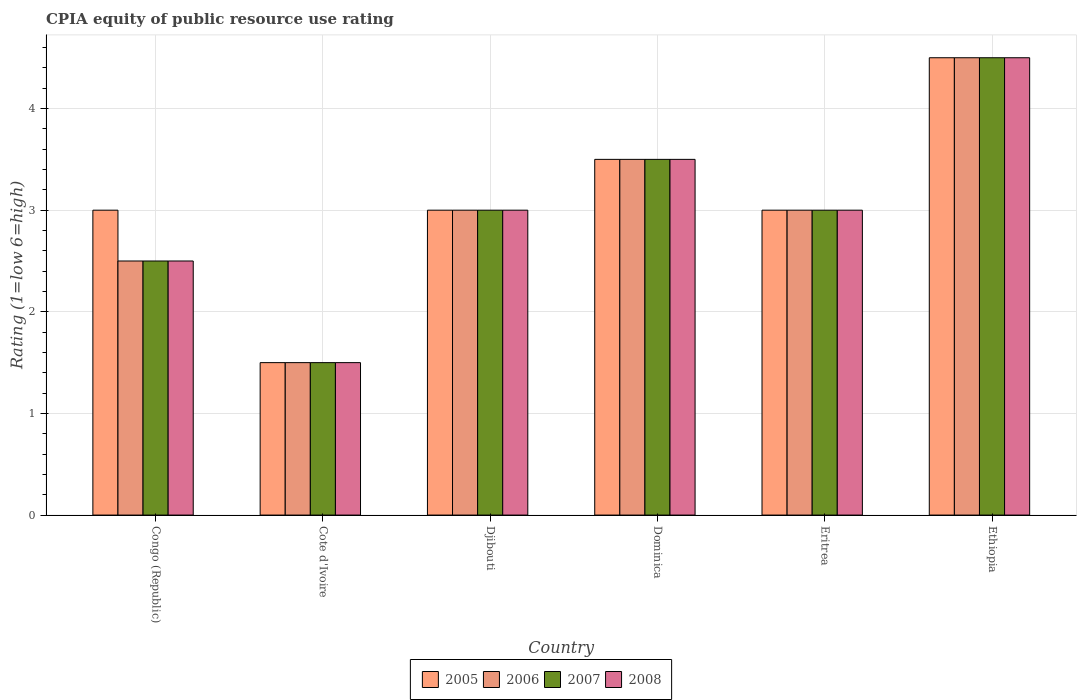How many different coloured bars are there?
Offer a very short reply. 4. How many groups of bars are there?
Give a very brief answer. 6. Are the number of bars on each tick of the X-axis equal?
Your response must be concise. Yes. What is the label of the 5th group of bars from the left?
Keep it short and to the point. Eritrea. Across all countries, what is the maximum CPIA rating in 2007?
Provide a short and direct response. 4.5. In which country was the CPIA rating in 2005 maximum?
Your answer should be compact. Ethiopia. In which country was the CPIA rating in 2005 minimum?
Offer a very short reply. Cote d'Ivoire. What is the total CPIA rating in 2006 in the graph?
Provide a succinct answer. 18. What is the difference between the CPIA rating in 2008 in Congo (Republic) and the CPIA rating in 2005 in Cote d'Ivoire?
Keep it short and to the point. 1. What is the difference between the CPIA rating of/in 2006 and CPIA rating of/in 2007 in Dominica?
Your response must be concise. 0. What is the ratio of the CPIA rating in 2005 in Congo (Republic) to that in Dominica?
Your answer should be very brief. 0.86. In how many countries, is the CPIA rating in 2005 greater than the average CPIA rating in 2005 taken over all countries?
Your response must be concise. 2. Is it the case that in every country, the sum of the CPIA rating in 2006 and CPIA rating in 2007 is greater than the sum of CPIA rating in 2008 and CPIA rating in 2005?
Your response must be concise. No. What does the 2nd bar from the left in Djibouti represents?
Offer a very short reply. 2006. Is it the case that in every country, the sum of the CPIA rating in 2007 and CPIA rating in 2006 is greater than the CPIA rating in 2008?
Offer a very short reply. Yes. Are all the bars in the graph horizontal?
Provide a succinct answer. No. Does the graph contain grids?
Keep it short and to the point. Yes. Where does the legend appear in the graph?
Keep it short and to the point. Bottom center. How many legend labels are there?
Provide a succinct answer. 4. What is the title of the graph?
Make the answer very short. CPIA equity of public resource use rating. What is the label or title of the Y-axis?
Provide a succinct answer. Rating (1=low 6=high). What is the Rating (1=low 6=high) in 2005 in Congo (Republic)?
Make the answer very short. 3. What is the Rating (1=low 6=high) in 2007 in Congo (Republic)?
Give a very brief answer. 2.5. What is the Rating (1=low 6=high) in 2008 in Congo (Republic)?
Make the answer very short. 2.5. What is the Rating (1=low 6=high) of 2005 in Cote d'Ivoire?
Your answer should be compact. 1.5. What is the Rating (1=low 6=high) of 2007 in Cote d'Ivoire?
Provide a short and direct response. 1.5. What is the Rating (1=low 6=high) of 2008 in Cote d'Ivoire?
Your answer should be very brief. 1.5. What is the Rating (1=low 6=high) of 2005 in Djibouti?
Make the answer very short. 3. What is the Rating (1=low 6=high) in 2006 in Djibouti?
Offer a very short reply. 3. What is the Rating (1=low 6=high) of 2007 in Djibouti?
Provide a succinct answer. 3. What is the Rating (1=low 6=high) of 2008 in Djibouti?
Offer a very short reply. 3. What is the Rating (1=low 6=high) of 2007 in Dominica?
Keep it short and to the point. 3.5. What is the Rating (1=low 6=high) of 2006 in Eritrea?
Make the answer very short. 3. What is the Rating (1=low 6=high) of 2007 in Eritrea?
Keep it short and to the point. 3. What is the Rating (1=low 6=high) in 2008 in Eritrea?
Your answer should be very brief. 3. Across all countries, what is the minimum Rating (1=low 6=high) of 2005?
Provide a short and direct response. 1.5. Across all countries, what is the minimum Rating (1=low 6=high) in 2006?
Your answer should be very brief. 1.5. Across all countries, what is the minimum Rating (1=low 6=high) of 2007?
Ensure brevity in your answer.  1.5. What is the total Rating (1=low 6=high) of 2005 in the graph?
Your response must be concise. 18.5. What is the total Rating (1=low 6=high) of 2007 in the graph?
Provide a short and direct response. 18. What is the difference between the Rating (1=low 6=high) of 2005 in Congo (Republic) and that in Cote d'Ivoire?
Provide a succinct answer. 1.5. What is the difference between the Rating (1=low 6=high) in 2007 in Congo (Republic) and that in Cote d'Ivoire?
Ensure brevity in your answer.  1. What is the difference between the Rating (1=low 6=high) in 2008 in Congo (Republic) and that in Cote d'Ivoire?
Make the answer very short. 1. What is the difference between the Rating (1=low 6=high) in 2008 in Congo (Republic) and that in Djibouti?
Keep it short and to the point. -0.5. What is the difference between the Rating (1=low 6=high) of 2006 in Congo (Republic) and that in Dominica?
Your answer should be compact. -1. What is the difference between the Rating (1=low 6=high) of 2007 in Congo (Republic) and that in Dominica?
Make the answer very short. -1. What is the difference between the Rating (1=low 6=high) of 2008 in Congo (Republic) and that in Dominica?
Ensure brevity in your answer.  -1. What is the difference between the Rating (1=low 6=high) in 2008 in Congo (Republic) and that in Eritrea?
Provide a short and direct response. -0.5. What is the difference between the Rating (1=low 6=high) in 2005 in Congo (Republic) and that in Ethiopia?
Your answer should be compact. -1.5. What is the difference between the Rating (1=low 6=high) in 2006 in Congo (Republic) and that in Ethiopia?
Your answer should be very brief. -2. What is the difference between the Rating (1=low 6=high) of 2007 in Congo (Republic) and that in Ethiopia?
Ensure brevity in your answer.  -2. What is the difference between the Rating (1=low 6=high) of 2008 in Congo (Republic) and that in Ethiopia?
Provide a succinct answer. -2. What is the difference between the Rating (1=low 6=high) in 2005 in Cote d'Ivoire and that in Djibouti?
Make the answer very short. -1.5. What is the difference between the Rating (1=low 6=high) in 2007 in Cote d'Ivoire and that in Djibouti?
Provide a short and direct response. -1.5. What is the difference between the Rating (1=low 6=high) of 2005 in Cote d'Ivoire and that in Dominica?
Keep it short and to the point. -2. What is the difference between the Rating (1=low 6=high) in 2007 in Cote d'Ivoire and that in Dominica?
Offer a very short reply. -2. What is the difference between the Rating (1=low 6=high) in 2008 in Cote d'Ivoire and that in Dominica?
Offer a terse response. -2. What is the difference between the Rating (1=low 6=high) in 2006 in Cote d'Ivoire and that in Eritrea?
Offer a very short reply. -1.5. What is the difference between the Rating (1=low 6=high) of 2005 in Cote d'Ivoire and that in Ethiopia?
Provide a succinct answer. -3. What is the difference between the Rating (1=low 6=high) of 2006 in Cote d'Ivoire and that in Ethiopia?
Your answer should be very brief. -3. What is the difference between the Rating (1=low 6=high) in 2007 in Cote d'Ivoire and that in Ethiopia?
Provide a succinct answer. -3. What is the difference between the Rating (1=low 6=high) in 2008 in Cote d'Ivoire and that in Ethiopia?
Provide a succinct answer. -3. What is the difference between the Rating (1=low 6=high) of 2006 in Djibouti and that in Dominica?
Keep it short and to the point. -0.5. What is the difference between the Rating (1=low 6=high) of 2008 in Djibouti and that in Dominica?
Make the answer very short. -0.5. What is the difference between the Rating (1=low 6=high) of 2005 in Djibouti and that in Eritrea?
Your answer should be compact. 0. What is the difference between the Rating (1=low 6=high) of 2006 in Djibouti and that in Eritrea?
Offer a very short reply. 0. What is the difference between the Rating (1=low 6=high) of 2007 in Djibouti and that in Eritrea?
Keep it short and to the point. 0. What is the difference between the Rating (1=low 6=high) in 2008 in Djibouti and that in Eritrea?
Your answer should be compact. 0. What is the difference between the Rating (1=low 6=high) in 2005 in Djibouti and that in Ethiopia?
Give a very brief answer. -1.5. What is the difference between the Rating (1=low 6=high) in 2006 in Djibouti and that in Ethiopia?
Keep it short and to the point. -1.5. What is the difference between the Rating (1=low 6=high) in 2007 in Djibouti and that in Ethiopia?
Make the answer very short. -1.5. What is the difference between the Rating (1=low 6=high) in 2005 in Dominica and that in Eritrea?
Ensure brevity in your answer.  0.5. What is the difference between the Rating (1=low 6=high) of 2006 in Dominica and that in Eritrea?
Offer a terse response. 0.5. What is the difference between the Rating (1=low 6=high) in 2007 in Dominica and that in Eritrea?
Keep it short and to the point. 0.5. What is the difference between the Rating (1=low 6=high) of 2008 in Dominica and that in Eritrea?
Offer a very short reply. 0.5. What is the difference between the Rating (1=low 6=high) of 2005 in Dominica and that in Ethiopia?
Your answer should be very brief. -1. What is the difference between the Rating (1=low 6=high) in 2006 in Dominica and that in Ethiopia?
Ensure brevity in your answer.  -1. What is the difference between the Rating (1=low 6=high) in 2008 in Dominica and that in Ethiopia?
Your answer should be compact. -1. What is the difference between the Rating (1=low 6=high) in 2005 in Congo (Republic) and the Rating (1=low 6=high) in 2008 in Cote d'Ivoire?
Keep it short and to the point. 1.5. What is the difference between the Rating (1=low 6=high) in 2006 in Congo (Republic) and the Rating (1=low 6=high) in 2007 in Cote d'Ivoire?
Provide a short and direct response. 1. What is the difference between the Rating (1=low 6=high) in 2006 in Congo (Republic) and the Rating (1=low 6=high) in 2008 in Cote d'Ivoire?
Provide a succinct answer. 1. What is the difference between the Rating (1=low 6=high) of 2007 in Congo (Republic) and the Rating (1=low 6=high) of 2008 in Cote d'Ivoire?
Keep it short and to the point. 1. What is the difference between the Rating (1=low 6=high) in 2005 in Congo (Republic) and the Rating (1=low 6=high) in 2007 in Djibouti?
Provide a short and direct response. 0. What is the difference between the Rating (1=low 6=high) in 2006 in Congo (Republic) and the Rating (1=low 6=high) in 2007 in Djibouti?
Provide a short and direct response. -0.5. What is the difference between the Rating (1=low 6=high) of 2006 in Congo (Republic) and the Rating (1=low 6=high) of 2008 in Djibouti?
Provide a succinct answer. -0.5. What is the difference between the Rating (1=low 6=high) in 2005 in Congo (Republic) and the Rating (1=low 6=high) in 2007 in Dominica?
Make the answer very short. -0.5. What is the difference between the Rating (1=low 6=high) of 2005 in Congo (Republic) and the Rating (1=low 6=high) of 2008 in Dominica?
Keep it short and to the point. -0.5. What is the difference between the Rating (1=low 6=high) of 2006 in Congo (Republic) and the Rating (1=low 6=high) of 2007 in Dominica?
Provide a succinct answer. -1. What is the difference between the Rating (1=low 6=high) of 2006 in Congo (Republic) and the Rating (1=low 6=high) of 2008 in Dominica?
Give a very brief answer. -1. What is the difference between the Rating (1=low 6=high) in 2007 in Congo (Republic) and the Rating (1=low 6=high) in 2008 in Dominica?
Make the answer very short. -1. What is the difference between the Rating (1=low 6=high) of 2005 in Congo (Republic) and the Rating (1=low 6=high) of 2008 in Eritrea?
Provide a short and direct response. 0. What is the difference between the Rating (1=low 6=high) of 2006 in Congo (Republic) and the Rating (1=low 6=high) of 2007 in Eritrea?
Provide a short and direct response. -0.5. What is the difference between the Rating (1=low 6=high) in 2006 in Congo (Republic) and the Rating (1=low 6=high) in 2008 in Eritrea?
Ensure brevity in your answer.  -0.5. What is the difference between the Rating (1=low 6=high) in 2007 in Congo (Republic) and the Rating (1=low 6=high) in 2008 in Eritrea?
Offer a very short reply. -0.5. What is the difference between the Rating (1=low 6=high) of 2005 in Congo (Republic) and the Rating (1=low 6=high) of 2006 in Ethiopia?
Your answer should be compact. -1.5. What is the difference between the Rating (1=low 6=high) of 2005 in Congo (Republic) and the Rating (1=low 6=high) of 2008 in Ethiopia?
Make the answer very short. -1.5. What is the difference between the Rating (1=low 6=high) in 2006 in Congo (Republic) and the Rating (1=low 6=high) in 2007 in Ethiopia?
Offer a terse response. -2. What is the difference between the Rating (1=low 6=high) of 2007 in Congo (Republic) and the Rating (1=low 6=high) of 2008 in Ethiopia?
Your response must be concise. -2. What is the difference between the Rating (1=low 6=high) of 2005 in Cote d'Ivoire and the Rating (1=low 6=high) of 2007 in Djibouti?
Offer a very short reply. -1.5. What is the difference between the Rating (1=low 6=high) in 2005 in Cote d'Ivoire and the Rating (1=low 6=high) in 2008 in Djibouti?
Make the answer very short. -1.5. What is the difference between the Rating (1=low 6=high) of 2006 in Cote d'Ivoire and the Rating (1=low 6=high) of 2007 in Djibouti?
Provide a short and direct response. -1.5. What is the difference between the Rating (1=low 6=high) of 2006 in Cote d'Ivoire and the Rating (1=low 6=high) of 2008 in Djibouti?
Offer a terse response. -1.5. What is the difference between the Rating (1=low 6=high) of 2007 in Cote d'Ivoire and the Rating (1=low 6=high) of 2008 in Djibouti?
Provide a short and direct response. -1.5. What is the difference between the Rating (1=low 6=high) of 2005 in Cote d'Ivoire and the Rating (1=low 6=high) of 2008 in Dominica?
Your answer should be compact. -2. What is the difference between the Rating (1=low 6=high) of 2006 in Cote d'Ivoire and the Rating (1=low 6=high) of 2008 in Dominica?
Provide a short and direct response. -2. What is the difference between the Rating (1=low 6=high) in 2007 in Cote d'Ivoire and the Rating (1=low 6=high) in 2008 in Dominica?
Offer a very short reply. -2. What is the difference between the Rating (1=low 6=high) in 2005 in Cote d'Ivoire and the Rating (1=low 6=high) in 2006 in Eritrea?
Keep it short and to the point. -1.5. What is the difference between the Rating (1=low 6=high) of 2005 in Cote d'Ivoire and the Rating (1=low 6=high) of 2007 in Eritrea?
Offer a very short reply. -1.5. What is the difference between the Rating (1=low 6=high) of 2005 in Cote d'Ivoire and the Rating (1=low 6=high) of 2008 in Eritrea?
Ensure brevity in your answer.  -1.5. What is the difference between the Rating (1=low 6=high) of 2006 in Cote d'Ivoire and the Rating (1=low 6=high) of 2008 in Eritrea?
Make the answer very short. -1.5. What is the difference between the Rating (1=low 6=high) of 2007 in Cote d'Ivoire and the Rating (1=low 6=high) of 2008 in Eritrea?
Offer a terse response. -1.5. What is the difference between the Rating (1=low 6=high) of 2005 in Cote d'Ivoire and the Rating (1=low 6=high) of 2007 in Ethiopia?
Give a very brief answer. -3. What is the difference between the Rating (1=low 6=high) in 2005 in Djibouti and the Rating (1=low 6=high) in 2007 in Dominica?
Keep it short and to the point. -0.5. What is the difference between the Rating (1=low 6=high) in 2005 in Djibouti and the Rating (1=low 6=high) in 2008 in Dominica?
Keep it short and to the point. -0.5. What is the difference between the Rating (1=low 6=high) of 2006 in Djibouti and the Rating (1=low 6=high) of 2007 in Dominica?
Provide a succinct answer. -0.5. What is the difference between the Rating (1=low 6=high) of 2007 in Djibouti and the Rating (1=low 6=high) of 2008 in Dominica?
Offer a very short reply. -0.5. What is the difference between the Rating (1=low 6=high) in 2005 in Djibouti and the Rating (1=low 6=high) in 2006 in Eritrea?
Your response must be concise. 0. What is the difference between the Rating (1=low 6=high) in 2005 in Djibouti and the Rating (1=low 6=high) in 2007 in Ethiopia?
Ensure brevity in your answer.  -1.5. What is the difference between the Rating (1=low 6=high) in 2006 in Djibouti and the Rating (1=low 6=high) in 2008 in Ethiopia?
Make the answer very short. -1.5. What is the difference between the Rating (1=low 6=high) of 2005 in Dominica and the Rating (1=low 6=high) of 2006 in Eritrea?
Give a very brief answer. 0.5. What is the difference between the Rating (1=low 6=high) of 2005 in Dominica and the Rating (1=low 6=high) of 2007 in Eritrea?
Your response must be concise. 0.5. What is the difference between the Rating (1=low 6=high) in 2006 in Dominica and the Rating (1=low 6=high) in 2007 in Eritrea?
Offer a terse response. 0.5. What is the difference between the Rating (1=low 6=high) in 2006 in Dominica and the Rating (1=low 6=high) in 2008 in Eritrea?
Offer a very short reply. 0.5. What is the difference between the Rating (1=low 6=high) in 2005 in Dominica and the Rating (1=low 6=high) in 2006 in Ethiopia?
Give a very brief answer. -1. What is the difference between the Rating (1=low 6=high) in 2006 in Dominica and the Rating (1=low 6=high) in 2007 in Ethiopia?
Your answer should be very brief. -1. What is the difference between the Rating (1=low 6=high) of 2007 in Dominica and the Rating (1=low 6=high) of 2008 in Ethiopia?
Provide a succinct answer. -1. What is the difference between the Rating (1=low 6=high) in 2006 in Eritrea and the Rating (1=low 6=high) in 2007 in Ethiopia?
Offer a terse response. -1.5. What is the average Rating (1=low 6=high) in 2005 per country?
Provide a short and direct response. 3.08. What is the average Rating (1=low 6=high) of 2006 per country?
Keep it short and to the point. 3. What is the average Rating (1=low 6=high) in 2007 per country?
Keep it short and to the point. 3. What is the average Rating (1=low 6=high) of 2008 per country?
Ensure brevity in your answer.  3. What is the difference between the Rating (1=low 6=high) of 2005 and Rating (1=low 6=high) of 2006 in Congo (Republic)?
Ensure brevity in your answer.  0.5. What is the difference between the Rating (1=low 6=high) in 2005 and Rating (1=low 6=high) in 2008 in Congo (Republic)?
Make the answer very short. 0.5. What is the difference between the Rating (1=low 6=high) in 2005 and Rating (1=low 6=high) in 2008 in Cote d'Ivoire?
Provide a short and direct response. 0. What is the difference between the Rating (1=low 6=high) of 2006 and Rating (1=low 6=high) of 2008 in Cote d'Ivoire?
Ensure brevity in your answer.  0. What is the difference between the Rating (1=low 6=high) in 2005 and Rating (1=low 6=high) in 2006 in Djibouti?
Provide a short and direct response. 0. What is the difference between the Rating (1=low 6=high) in 2005 and Rating (1=low 6=high) in 2008 in Djibouti?
Provide a succinct answer. 0. What is the difference between the Rating (1=low 6=high) of 2007 and Rating (1=low 6=high) of 2008 in Djibouti?
Offer a very short reply. 0. What is the difference between the Rating (1=low 6=high) of 2005 and Rating (1=low 6=high) of 2007 in Dominica?
Provide a short and direct response. 0. What is the difference between the Rating (1=low 6=high) of 2006 and Rating (1=low 6=high) of 2008 in Dominica?
Provide a succinct answer. 0. What is the difference between the Rating (1=low 6=high) of 2005 and Rating (1=low 6=high) of 2008 in Eritrea?
Provide a short and direct response. 0. What is the difference between the Rating (1=low 6=high) of 2006 and Rating (1=low 6=high) of 2008 in Eritrea?
Provide a succinct answer. 0. What is the difference between the Rating (1=low 6=high) in 2005 and Rating (1=low 6=high) in 2007 in Ethiopia?
Provide a succinct answer. 0. What is the difference between the Rating (1=low 6=high) of 2005 and Rating (1=low 6=high) of 2008 in Ethiopia?
Offer a terse response. 0. What is the difference between the Rating (1=low 6=high) in 2006 and Rating (1=low 6=high) in 2007 in Ethiopia?
Give a very brief answer. 0. What is the difference between the Rating (1=low 6=high) in 2006 and Rating (1=low 6=high) in 2008 in Ethiopia?
Make the answer very short. 0. What is the difference between the Rating (1=low 6=high) in 2007 and Rating (1=low 6=high) in 2008 in Ethiopia?
Offer a terse response. 0. What is the ratio of the Rating (1=low 6=high) of 2008 in Congo (Republic) to that in Cote d'Ivoire?
Provide a short and direct response. 1.67. What is the ratio of the Rating (1=low 6=high) in 2005 in Congo (Republic) to that in Djibouti?
Offer a terse response. 1. What is the ratio of the Rating (1=low 6=high) in 2007 in Congo (Republic) to that in Djibouti?
Your response must be concise. 0.83. What is the ratio of the Rating (1=low 6=high) of 2008 in Congo (Republic) to that in Djibouti?
Your answer should be very brief. 0.83. What is the ratio of the Rating (1=low 6=high) of 2006 in Congo (Republic) to that in Dominica?
Your response must be concise. 0.71. What is the ratio of the Rating (1=low 6=high) in 2007 in Congo (Republic) to that in Dominica?
Offer a terse response. 0.71. What is the ratio of the Rating (1=low 6=high) in 2008 in Congo (Republic) to that in Dominica?
Offer a terse response. 0.71. What is the ratio of the Rating (1=low 6=high) of 2008 in Congo (Republic) to that in Eritrea?
Provide a short and direct response. 0.83. What is the ratio of the Rating (1=low 6=high) in 2005 in Congo (Republic) to that in Ethiopia?
Make the answer very short. 0.67. What is the ratio of the Rating (1=low 6=high) of 2006 in Congo (Republic) to that in Ethiopia?
Ensure brevity in your answer.  0.56. What is the ratio of the Rating (1=low 6=high) in 2007 in Congo (Republic) to that in Ethiopia?
Offer a terse response. 0.56. What is the ratio of the Rating (1=low 6=high) of 2008 in Congo (Republic) to that in Ethiopia?
Your answer should be compact. 0.56. What is the ratio of the Rating (1=low 6=high) of 2005 in Cote d'Ivoire to that in Djibouti?
Provide a succinct answer. 0.5. What is the ratio of the Rating (1=low 6=high) in 2006 in Cote d'Ivoire to that in Djibouti?
Keep it short and to the point. 0.5. What is the ratio of the Rating (1=low 6=high) of 2007 in Cote d'Ivoire to that in Djibouti?
Your answer should be compact. 0.5. What is the ratio of the Rating (1=low 6=high) of 2005 in Cote d'Ivoire to that in Dominica?
Keep it short and to the point. 0.43. What is the ratio of the Rating (1=low 6=high) in 2006 in Cote d'Ivoire to that in Dominica?
Your answer should be compact. 0.43. What is the ratio of the Rating (1=low 6=high) of 2007 in Cote d'Ivoire to that in Dominica?
Provide a succinct answer. 0.43. What is the ratio of the Rating (1=low 6=high) of 2008 in Cote d'Ivoire to that in Dominica?
Offer a very short reply. 0.43. What is the ratio of the Rating (1=low 6=high) of 2006 in Cote d'Ivoire to that in Eritrea?
Provide a succinct answer. 0.5. What is the ratio of the Rating (1=low 6=high) in 2007 in Cote d'Ivoire to that in Eritrea?
Your answer should be compact. 0.5. What is the ratio of the Rating (1=low 6=high) in 2008 in Cote d'Ivoire to that in Eritrea?
Ensure brevity in your answer.  0.5. What is the ratio of the Rating (1=low 6=high) of 2005 in Cote d'Ivoire to that in Ethiopia?
Ensure brevity in your answer.  0.33. What is the ratio of the Rating (1=low 6=high) of 2006 in Cote d'Ivoire to that in Ethiopia?
Make the answer very short. 0.33. What is the ratio of the Rating (1=low 6=high) in 2008 in Cote d'Ivoire to that in Ethiopia?
Offer a terse response. 0.33. What is the ratio of the Rating (1=low 6=high) in 2006 in Djibouti to that in Dominica?
Your response must be concise. 0.86. What is the ratio of the Rating (1=low 6=high) in 2007 in Djibouti to that in Dominica?
Provide a short and direct response. 0.86. What is the ratio of the Rating (1=low 6=high) in 2008 in Djibouti to that in Dominica?
Offer a terse response. 0.86. What is the ratio of the Rating (1=low 6=high) of 2006 in Djibouti to that in Eritrea?
Keep it short and to the point. 1. What is the ratio of the Rating (1=low 6=high) in 2007 in Djibouti to that in Eritrea?
Keep it short and to the point. 1. What is the ratio of the Rating (1=low 6=high) in 2008 in Djibouti to that in Eritrea?
Provide a succinct answer. 1. What is the ratio of the Rating (1=low 6=high) of 2005 in Djibouti to that in Ethiopia?
Offer a terse response. 0.67. What is the ratio of the Rating (1=low 6=high) in 2007 in Djibouti to that in Ethiopia?
Your answer should be very brief. 0.67. What is the ratio of the Rating (1=low 6=high) of 2005 in Dominica to that in Eritrea?
Your answer should be very brief. 1.17. What is the ratio of the Rating (1=low 6=high) of 2008 in Dominica to that in Eritrea?
Your response must be concise. 1.17. What is the ratio of the Rating (1=low 6=high) in 2005 in Dominica to that in Ethiopia?
Ensure brevity in your answer.  0.78. What is the ratio of the Rating (1=low 6=high) of 2008 in Dominica to that in Ethiopia?
Provide a short and direct response. 0.78. What is the ratio of the Rating (1=low 6=high) in 2005 in Eritrea to that in Ethiopia?
Provide a succinct answer. 0.67. What is the ratio of the Rating (1=low 6=high) in 2006 in Eritrea to that in Ethiopia?
Your response must be concise. 0.67. What is the ratio of the Rating (1=low 6=high) of 2008 in Eritrea to that in Ethiopia?
Give a very brief answer. 0.67. What is the difference between the highest and the second highest Rating (1=low 6=high) of 2008?
Provide a short and direct response. 1. What is the difference between the highest and the lowest Rating (1=low 6=high) in 2006?
Your answer should be very brief. 3. What is the difference between the highest and the lowest Rating (1=low 6=high) in 2007?
Make the answer very short. 3. 